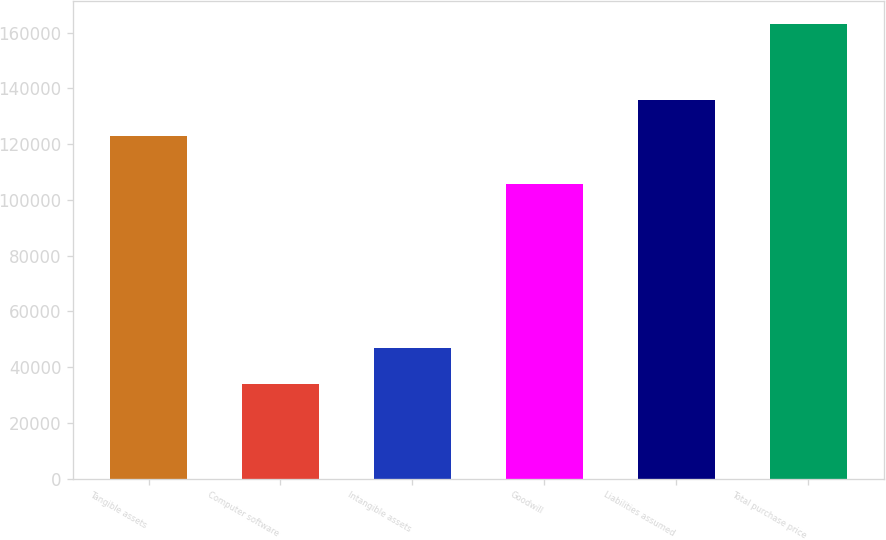<chart> <loc_0><loc_0><loc_500><loc_500><bar_chart><fcel>Tangible assets<fcel>Computer software<fcel>Intangible assets<fcel>Goodwill<fcel>Liabilities assumed<fcel>Total purchase price<nl><fcel>122938<fcel>34039<fcel>46959.7<fcel>105664<fcel>135859<fcel>163246<nl></chart> 